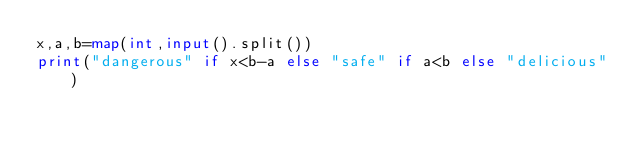Convert code to text. <code><loc_0><loc_0><loc_500><loc_500><_Python_>x,a,b=map(int,input().split())
print("dangerous" if x<b-a else "safe" if a<b else "delicious")</code> 